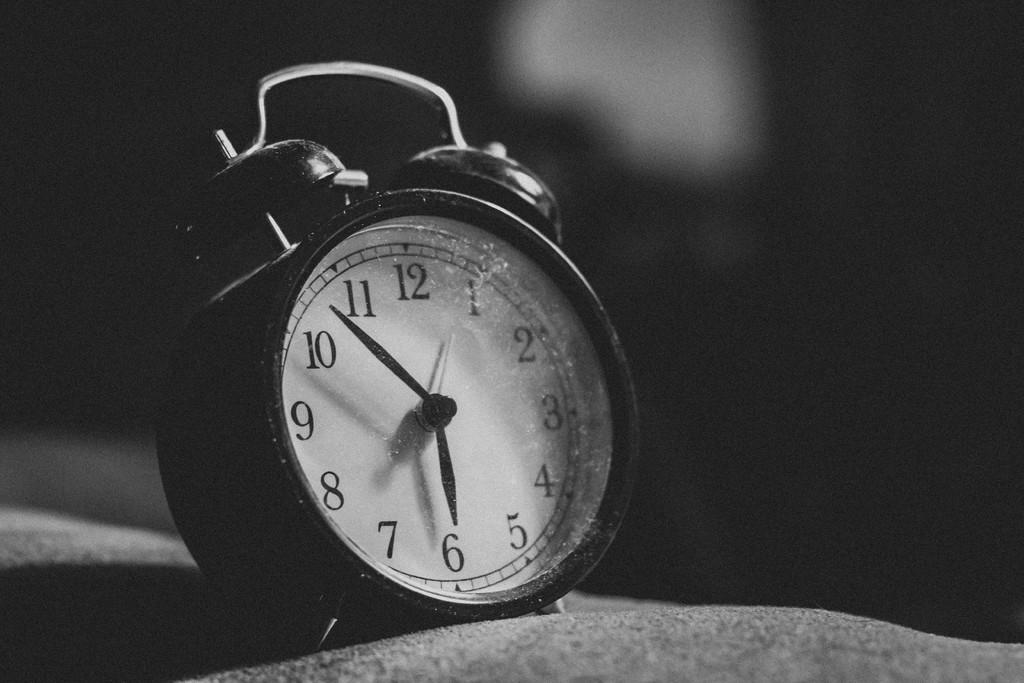<image>
Summarize the visual content of the image. A black and white clock with the hands at 5:53. 